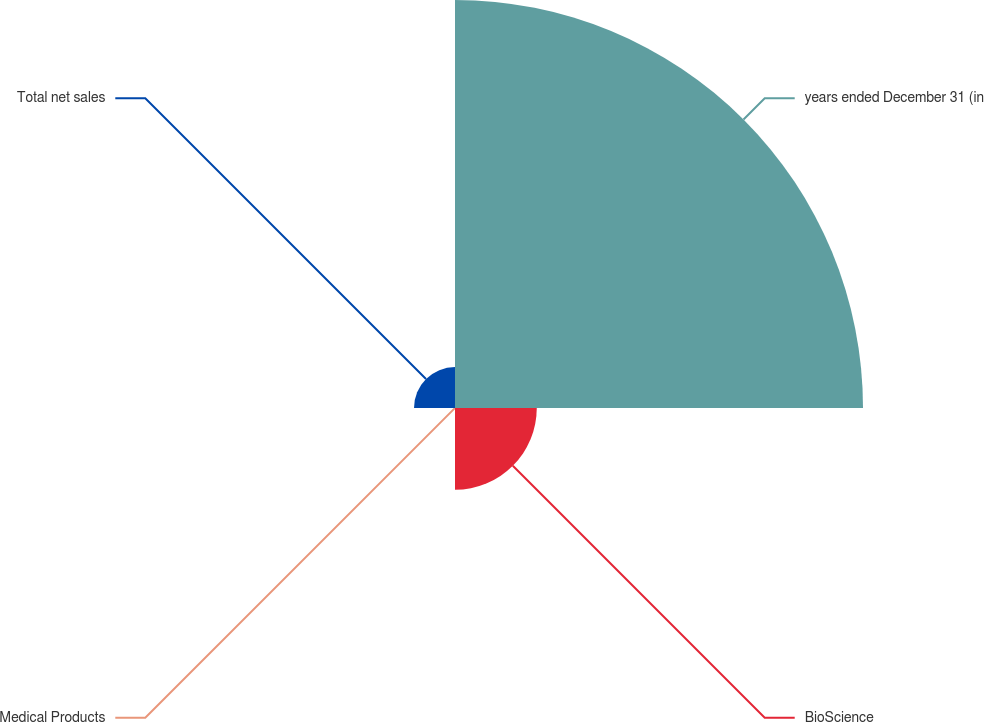Convert chart. <chart><loc_0><loc_0><loc_500><loc_500><pie_chart><fcel>years ended December 31 (in<fcel>BioScience<fcel>Medical Products<fcel>Total net sales<nl><fcel>76.84%<fcel>15.4%<fcel>0.04%<fcel>7.72%<nl></chart> 